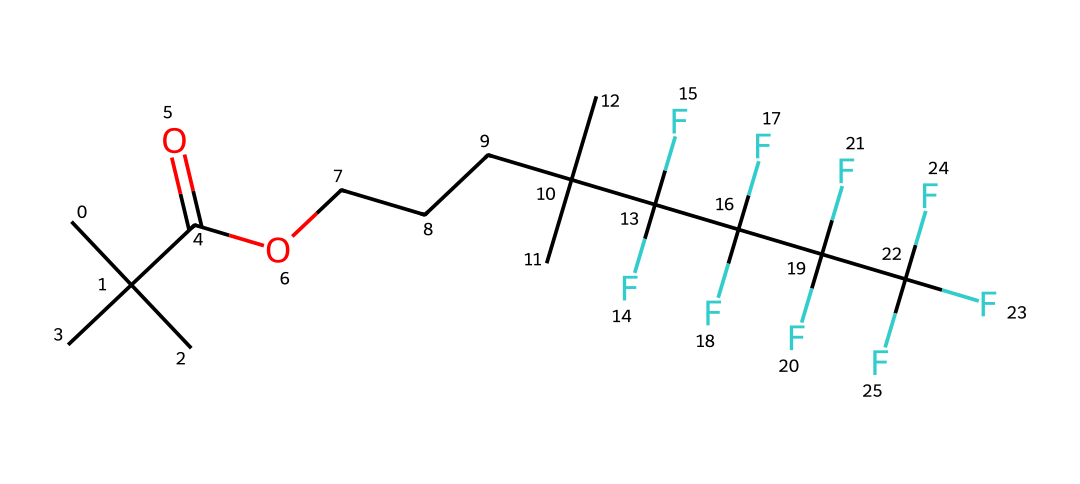what is the main functional group present in this chemical? The structure includes a carboxylic acid group, which is identified by the -COOH notation in the SMILES representation. This is indicated by the carbon atom (C) double-bonded to an oxygen atom (O) and single-bonded to a hydroxyl group (-OH).
Answer: carboxylic acid how many carbon atoms are in this chemical? By analyzing the SMILES string, we can count each carbon (C) atom. The chain has 15 carbon atoms in total, visible through the repeated 'C' characters along with the branched notations.
Answer: 15 what is the primary characteristic of this polymer related to its application in sportswear? The presence of fluorine atoms (F) in the structure contributes to the compound's hydrophobic properties, making it waterproof, ideal for all-weather sportswear. This is identified by the pentafluorinated sections of the structure.
Answer: waterproof what is the total number of fluorine atoms in this chemical? The SMILES representation shows a total of 5 fluorine (F) atoms, as indicated by the repetition of 'F' symbols in the structure, particularly in one of the branched chains.
Answer: 5 what type of polymer can be synthesized from this chemical? This compound can form a fluoropolymer, a type of polymer that typically exhibits excellent chemical resistance and low surface energy due to the presence of fluorine atoms.
Answer: fluoropolymer which feature in the structure indicates its potential for flexibility? The presence of branched carbon structures throughout the molecule allows for greater rotation and movement within the chains, which contributes to the flexibility of the resulting polymer.
Answer: branched structure 